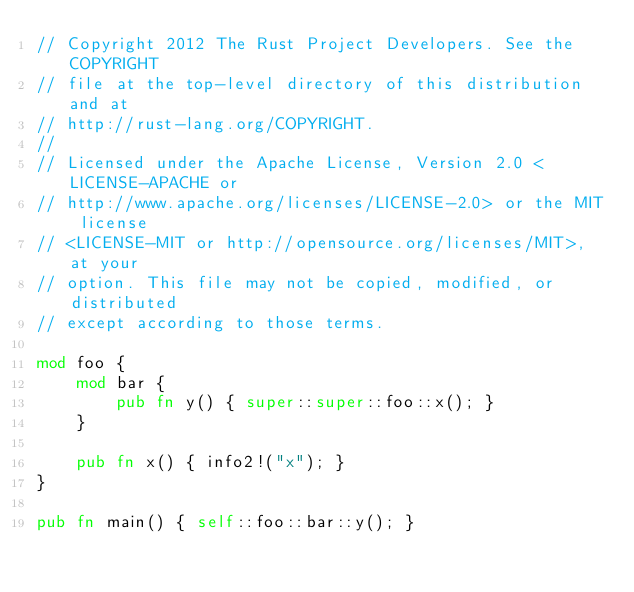Convert code to text. <code><loc_0><loc_0><loc_500><loc_500><_Rust_>// Copyright 2012 The Rust Project Developers. See the COPYRIGHT
// file at the top-level directory of this distribution and at
// http://rust-lang.org/COPYRIGHT.
//
// Licensed under the Apache License, Version 2.0 <LICENSE-APACHE or
// http://www.apache.org/licenses/LICENSE-2.0> or the MIT license
// <LICENSE-MIT or http://opensource.org/licenses/MIT>, at your
// option. This file may not be copied, modified, or distributed
// except according to those terms.

mod foo {
    mod bar {
        pub fn y() { super::super::foo::x(); }
    }

    pub fn x() { info2!("x"); }
}

pub fn main() { self::foo::bar::y(); }
</code> 